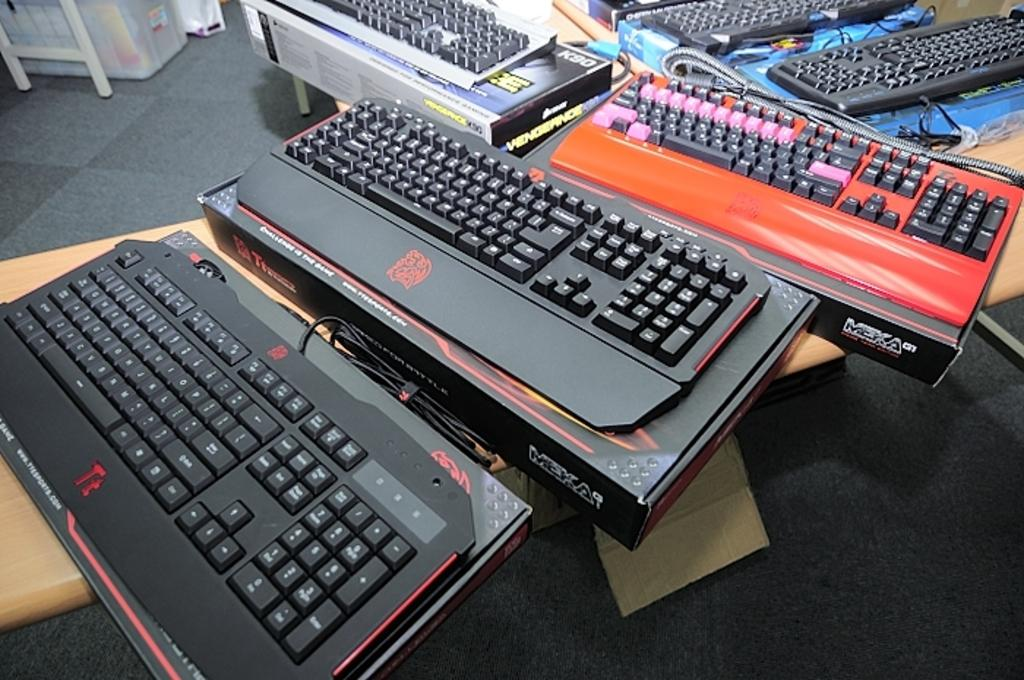Provide a one-sentence caption for the provided image. Several Meka computer keyboards are on tables inside a building. 